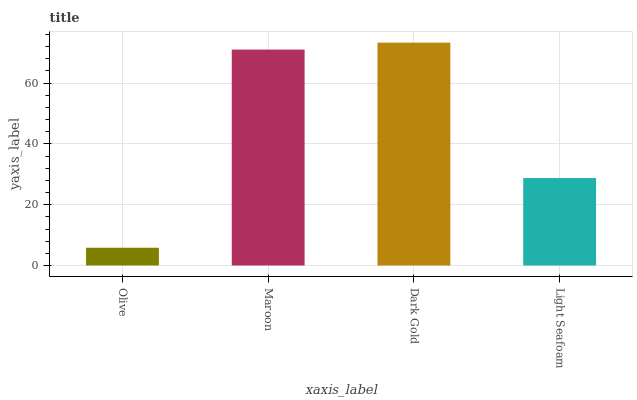Is Olive the minimum?
Answer yes or no. Yes. Is Dark Gold the maximum?
Answer yes or no. Yes. Is Maroon the minimum?
Answer yes or no. No. Is Maroon the maximum?
Answer yes or no. No. Is Maroon greater than Olive?
Answer yes or no. Yes. Is Olive less than Maroon?
Answer yes or no. Yes. Is Olive greater than Maroon?
Answer yes or no. No. Is Maroon less than Olive?
Answer yes or no. No. Is Maroon the high median?
Answer yes or no. Yes. Is Light Seafoam the low median?
Answer yes or no. Yes. Is Dark Gold the high median?
Answer yes or no. No. Is Dark Gold the low median?
Answer yes or no. No. 